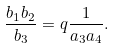<formula> <loc_0><loc_0><loc_500><loc_500>\frac { b _ { 1 } b _ { 2 } } { b _ { 3 } } = q \frac { 1 } { a _ { 3 } a _ { 4 } } .</formula> 